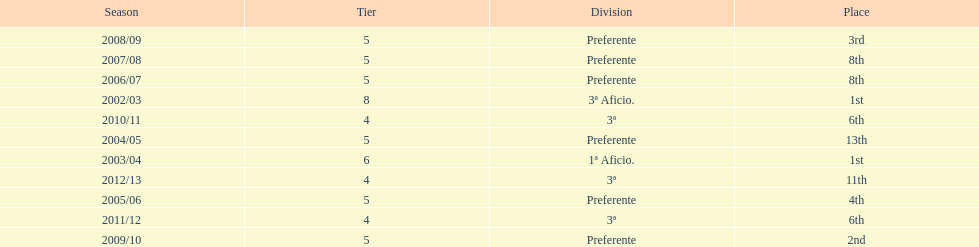Which division placed more than aficio 1a and 3a? Preferente. Could you help me parse every detail presented in this table? {'header': ['Season', 'Tier', 'Division', 'Place'], 'rows': [['2008/09', '5', 'Preferente', '3rd'], ['2007/08', '5', 'Preferente', '8th'], ['2006/07', '5', 'Preferente', '8th'], ['2002/03', '8', '3ª Aficio.', '1st'], ['2010/11', '4', '3ª', '6th'], ['2004/05', '5', 'Preferente', '13th'], ['2003/04', '6', '1ª Aficio.', '1st'], ['2012/13', '4', '3ª', '11th'], ['2005/06', '5', 'Preferente', '4th'], ['2011/12', '4', '3ª', '6th'], ['2009/10', '5', 'Preferente', '2nd']]} 